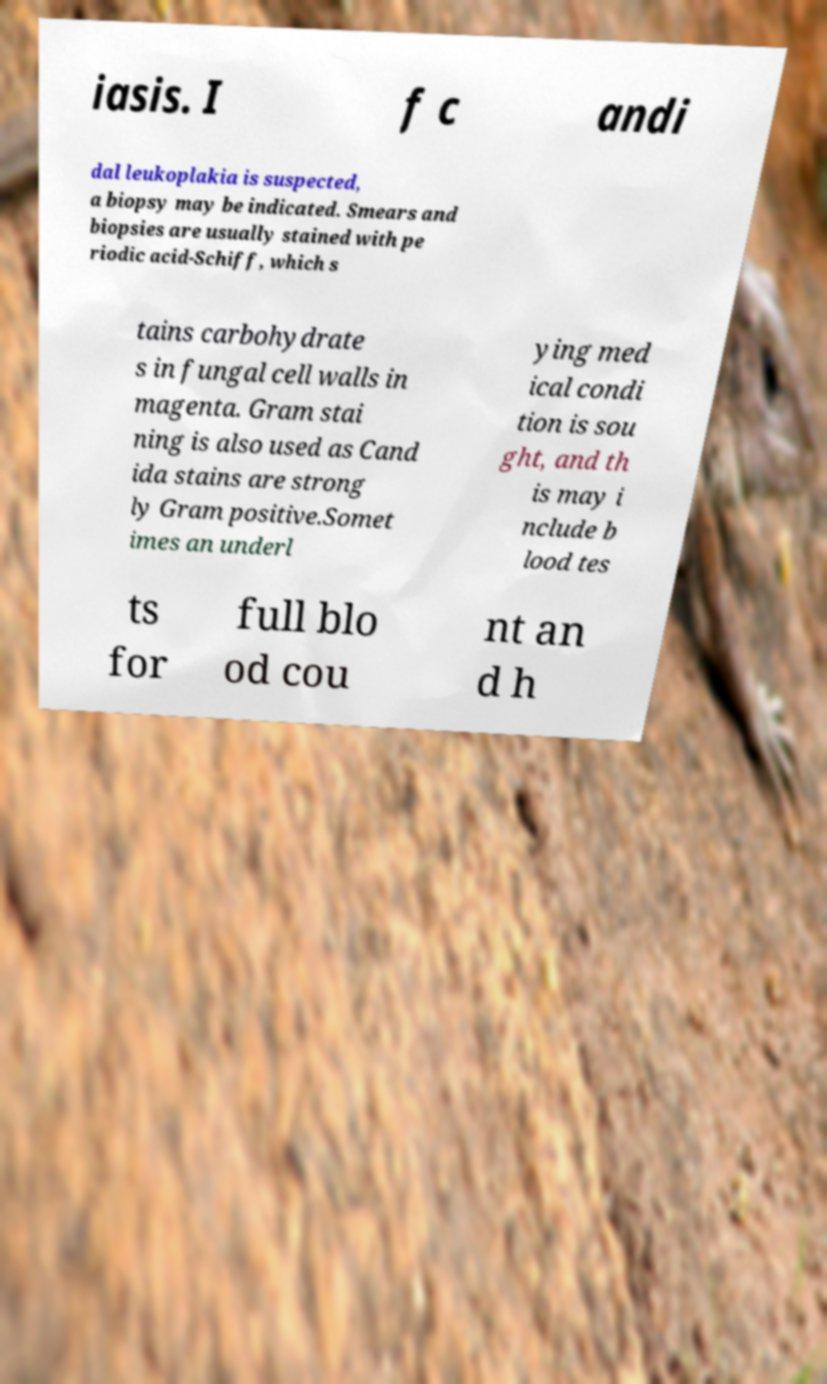There's text embedded in this image that I need extracted. Can you transcribe it verbatim? iasis. I f c andi dal leukoplakia is suspected, a biopsy may be indicated. Smears and biopsies are usually stained with pe riodic acid-Schiff, which s tains carbohydrate s in fungal cell walls in magenta. Gram stai ning is also used as Cand ida stains are strong ly Gram positive.Somet imes an underl ying med ical condi tion is sou ght, and th is may i nclude b lood tes ts for full blo od cou nt an d h 